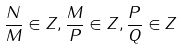Convert formula to latex. <formula><loc_0><loc_0><loc_500><loc_500>\frac { N } { M } \in Z , \frac { M } { P } \in Z , \frac { P } { Q } \in Z</formula> 